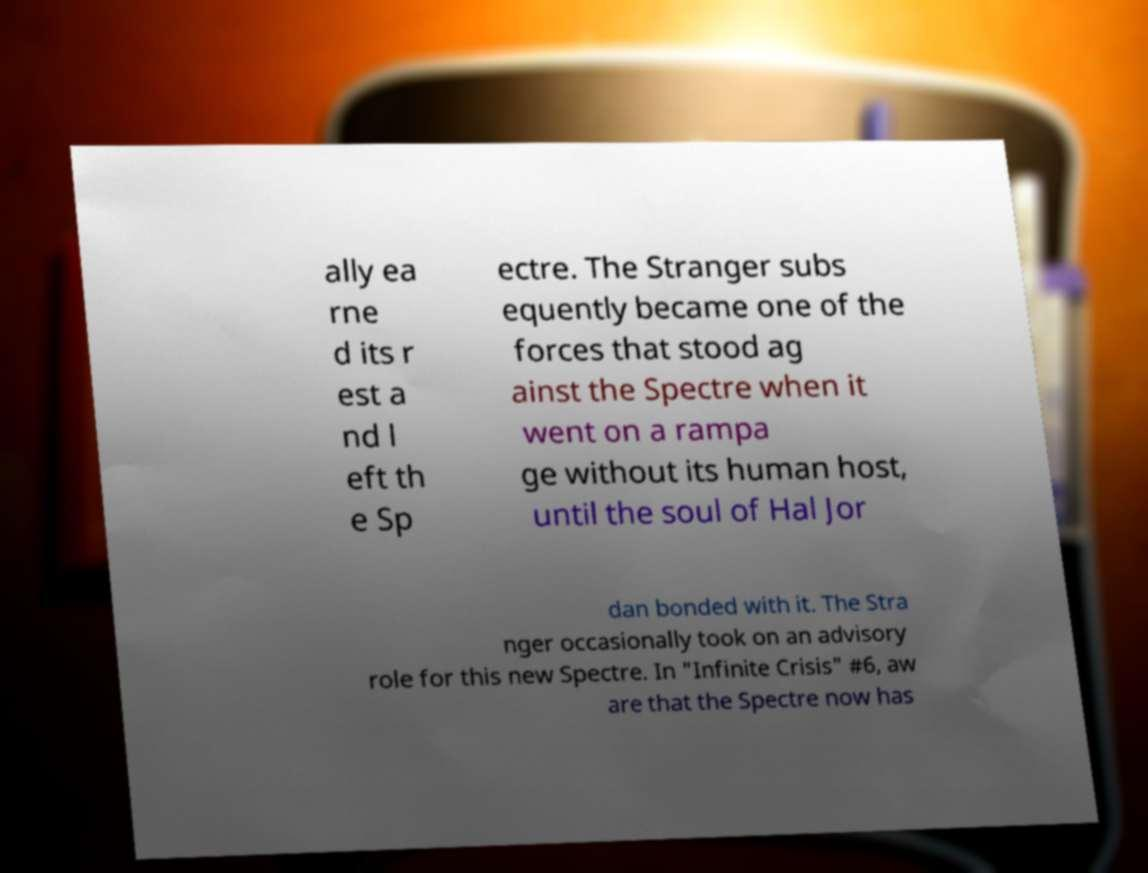Please identify and transcribe the text found in this image. ally ea rne d its r est a nd l eft th e Sp ectre. The Stranger subs equently became one of the forces that stood ag ainst the Spectre when it went on a rampa ge without its human host, until the soul of Hal Jor dan bonded with it. The Stra nger occasionally took on an advisory role for this new Spectre. In "Infinite Crisis" #6, aw are that the Spectre now has 